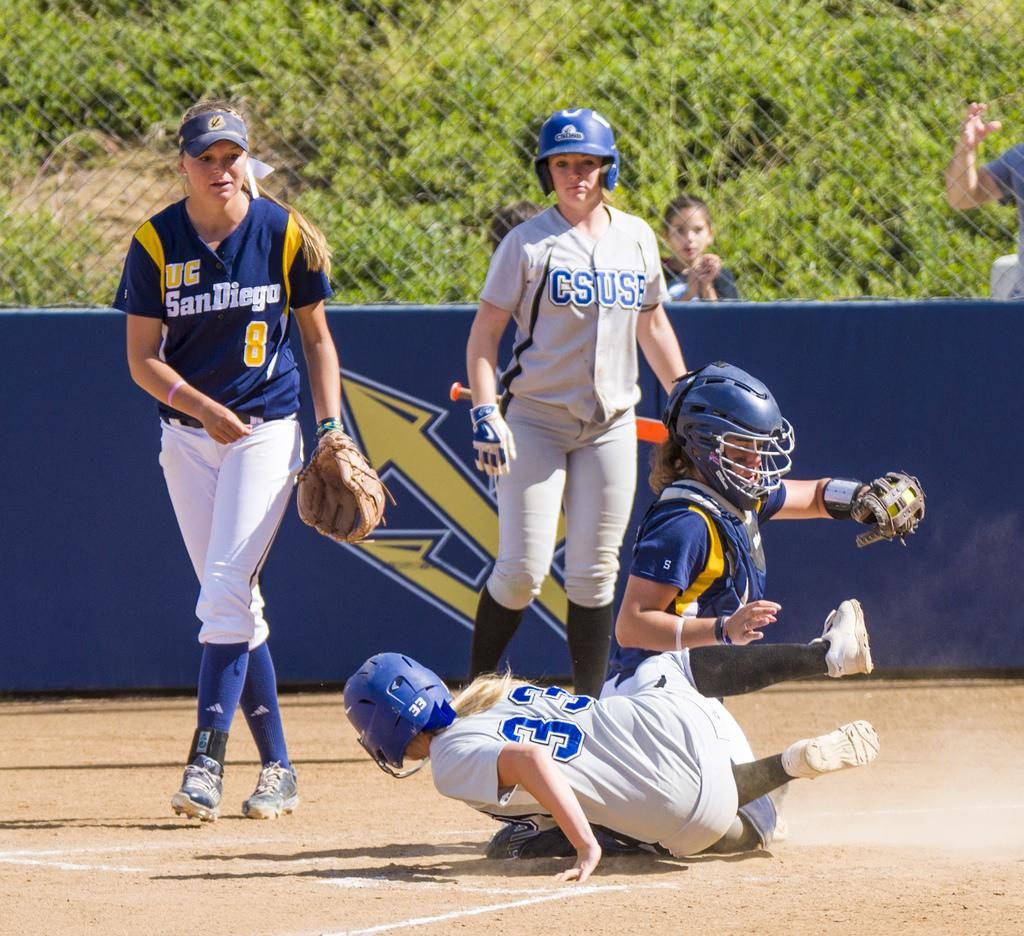<image>
Share a concise interpretation of the image provided. player number 33 in the grey team fell down 